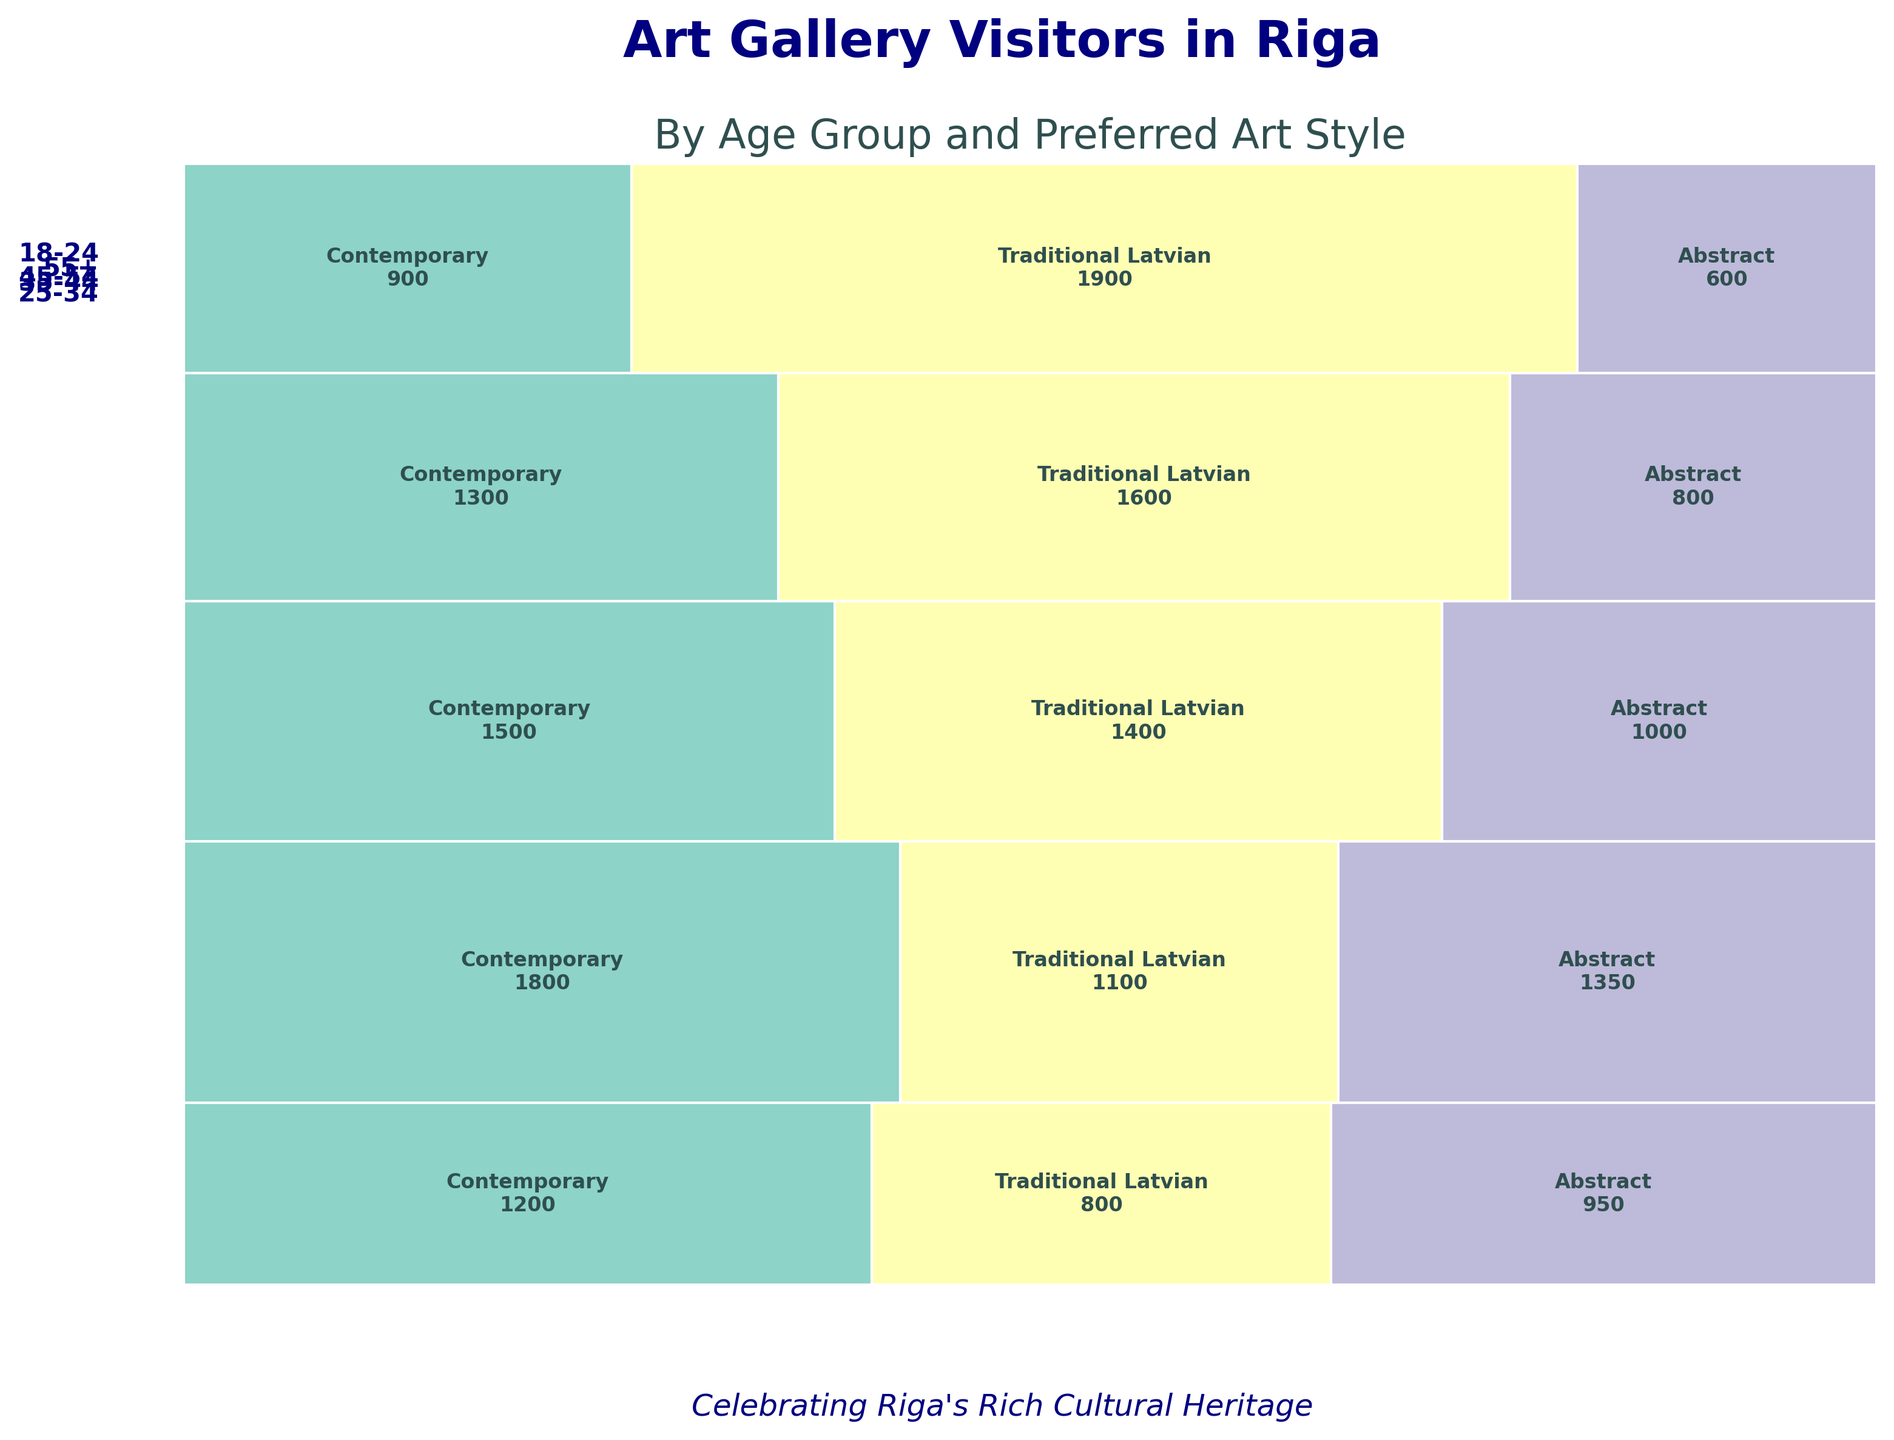How many art styles are displayed in the plot? The legend or segmentation within the rectangles shows different colors representing different art styles. By counting them, we find the total number of styles.
Answer: 3 Which age group has the highest number of visitors preferring Traditional Latvian art? We need to check the annotations on the rectangles for each age group under Traditional Latvian art to find the highest value.
Answer: 55+ What is the total number of visitors in the 18-24 age group? Sum the visitor numbers for each art style within the 18-24 age group: 1200 (Contemporary) + 800 (Traditional Latvian) + 950 (Abstract).
Answer: 2950 How does the preference for Contemporary art change with age? Observe the size of rectangles representing Contemporary art across different age groups. The size indicates the number of visitors, showing how preference increases or decreases with age.
Answer: Decreases Which art style has the least number of visitors in the 45-54 age group? Identify the smallest rectangles (or smallest visitor annotations) within the 45-54 age group.
Answer: Abstract Compare the number of visitors preferring Traditional Latvian art in the 25-34 and 35-44 age groups. Which group has more? Check the values of visitors for Traditional Latvian art in both age groups and compare them.
Answer: 35-44 How does the proportion of visitors preferring Abstract art compare between the 18-24 and 55+ age groups? Look at the relative widths of the rectangles for Abstract art within the 18-24 and 55+ age groups.
Answer: Higher in 18-24 What is the total number of visitors across all age groups for Contemporary art? Sum the visitor numbers for Contemporary art for all age groups: 1200 + 1800 + 1500 + 1300 + 900.
Answer: 6700 What is the most preferred art style for the 25-34 age group? Identify the largest rectangle or the highest visitor value within the 25-34 age group.
Answer: Contemporary Considering all age groups, which age group contributes the most to the total number of visitors? Sum the total visitors for each age group and compare. The group with the highest total is the answer.
Answer: 25-34 